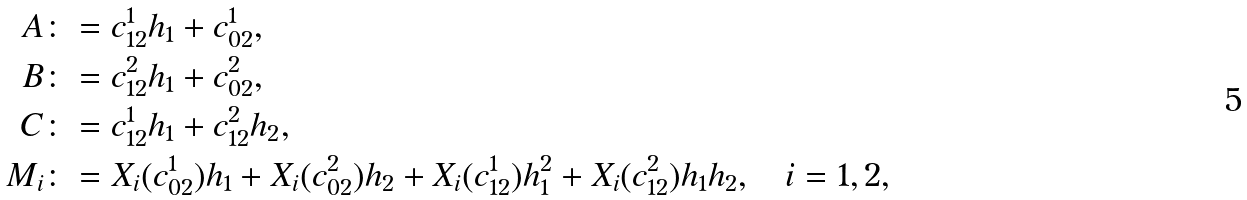<formula> <loc_0><loc_0><loc_500><loc_500>A & \colon = c _ { 1 2 } ^ { 1 } h _ { 1 } + c _ { 0 2 } ^ { 1 } , \\ B & \colon = c _ { 1 2 } ^ { 2 } h _ { 1 } + c _ { 0 2 } ^ { 2 } , \\ C & \colon = c _ { 1 2 } ^ { 1 } h _ { 1 } + c _ { 1 2 } ^ { 2 } h _ { 2 } , \\ M _ { i } & \colon = X _ { i } ( c _ { 0 2 } ^ { 1 } ) h _ { 1 } + X _ { i } ( c _ { 0 2 } ^ { 2 } ) h _ { 2 } + X _ { i } ( c _ { 1 2 } ^ { 1 } ) h _ { 1 } ^ { 2 } + X _ { i } ( c _ { 1 2 } ^ { 2 } ) h _ { 1 } h _ { 2 } , \quad i = 1 , 2 ,</formula> 